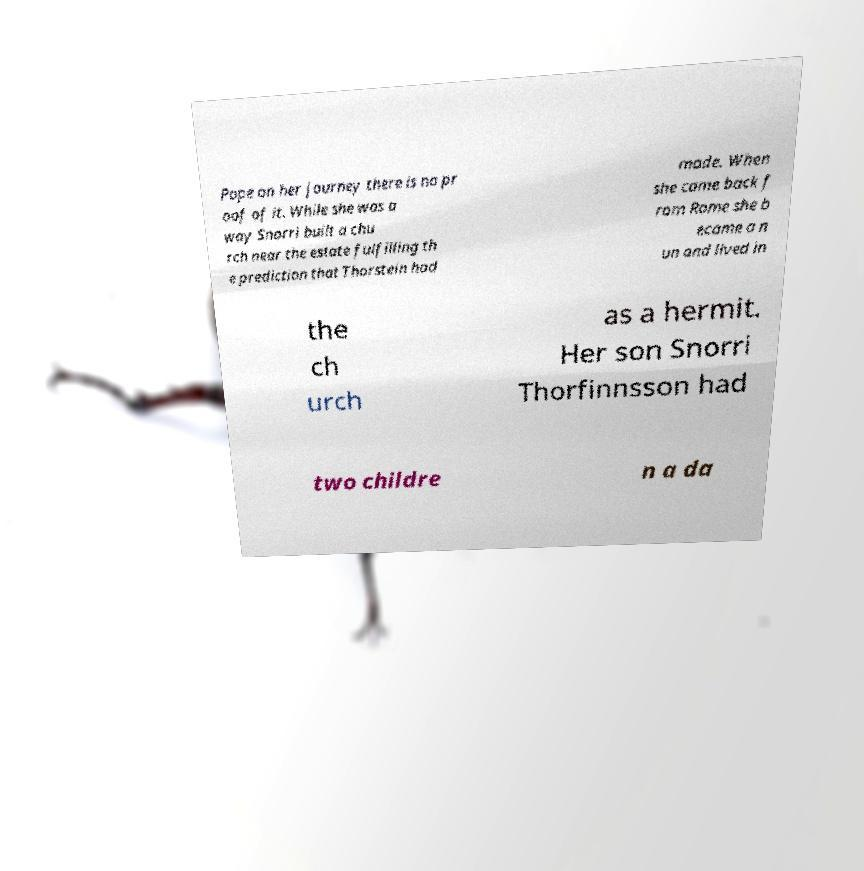Please read and relay the text visible in this image. What does it say? Pope on her journey there is no pr oof of it. While she was a way Snorri built a chu rch near the estate fulfilling th e prediction that Thorstein had made. When she came back f rom Rome she b ecame a n un and lived in the ch urch as a hermit. Her son Snorri Thorfinnsson had two childre n a da 